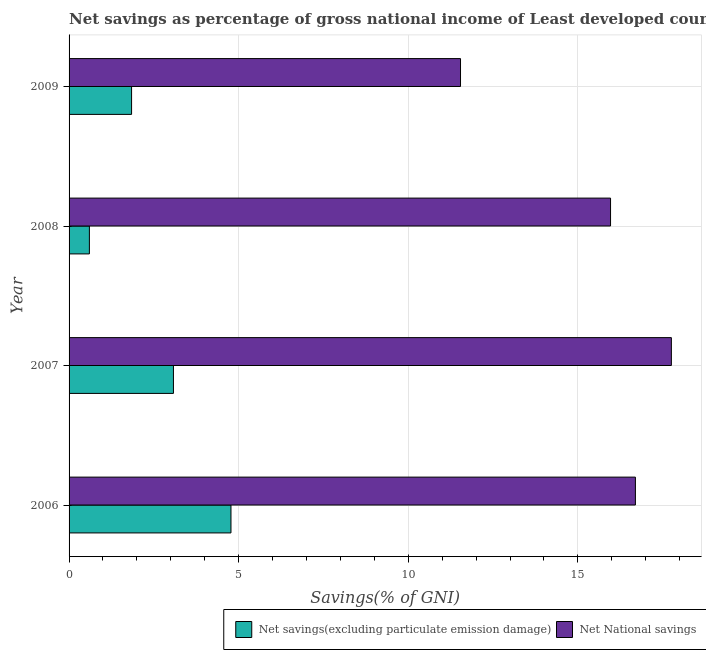Are the number of bars per tick equal to the number of legend labels?
Your answer should be compact. Yes. How many bars are there on the 4th tick from the top?
Offer a very short reply. 2. In how many cases, is the number of bars for a given year not equal to the number of legend labels?
Your answer should be compact. 0. What is the net savings(excluding particulate emission damage) in 2006?
Keep it short and to the point. 4.77. Across all years, what is the maximum net savings(excluding particulate emission damage)?
Your answer should be compact. 4.77. Across all years, what is the minimum net national savings?
Offer a very short reply. 11.54. In which year was the net savings(excluding particulate emission damage) maximum?
Offer a very short reply. 2006. In which year was the net national savings minimum?
Make the answer very short. 2009. What is the total net national savings in the graph?
Your answer should be compact. 61.96. What is the difference between the net savings(excluding particulate emission damage) in 2007 and that in 2008?
Your answer should be compact. 2.48. What is the difference between the net national savings in 2006 and the net savings(excluding particulate emission damage) in 2008?
Ensure brevity in your answer.  16.1. What is the average net national savings per year?
Keep it short and to the point. 15.49. In the year 2006, what is the difference between the net savings(excluding particulate emission damage) and net national savings?
Provide a short and direct response. -11.92. What is the ratio of the net national savings in 2006 to that in 2007?
Provide a short and direct response. 0.94. Is the difference between the net national savings in 2006 and 2007 greater than the difference between the net savings(excluding particulate emission damage) in 2006 and 2007?
Provide a short and direct response. No. What is the difference between the highest and the second highest net national savings?
Your response must be concise. 1.06. What is the difference between the highest and the lowest net national savings?
Your answer should be compact. 6.22. What does the 1st bar from the top in 2009 represents?
Offer a terse response. Net National savings. What does the 2nd bar from the bottom in 2008 represents?
Offer a very short reply. Net National savings. How many bars are there?
Your response must be concise. 8. Are all the bars in the graph horizontal?
Your answer should be compact. Yes. How many years are there in the graph?
Offer a terse response. 4. What is the difference between two consecutive major ticks on the X-axis?
Your answer should be very brief. 5. Are the values on the major ticks of X-axis written in scientific E-notation?
Your response must be concise. No. Does the graph contain grids?
Ensure brevity in your answer.  Yes. How many legend labels are there?
Your answer should be very brief. 2. How are the legend labels stacked?
Your answer should be very brief. Horizontal. What is the title of the graph?
Ensure brevity in your answer.  Net savings as percentage of gross national income of Least developed countries. What is the label or title of the X-axis?
Your answer should be compact. Savings(% of GNI). What is the label or title of the Y-axis?
Provide a succinct answer. Year. What is the Savings(% of GNI) in Net savings(excluding particulate emission damage) in 2006?
Provide a short and direct response. 4.77. What is the Savings(% of GNI) in Net National savings in 2006?
Give a very brief answer. 16.7. What is the Savings(% of GNI) of Net savings(excluding particulate emission damage) in 2007?
Your answer should be very brief. 3.08. What is the Savings(% of GNI) in Net National savings in 2007?
Your answer should be compact. 17.76. What is the Savings(% of GNI) of Net savings(excluding particulate emission damage) in 2008?
Your answer should be very brief. 0.6. What is the Savings(% of GNI) of Net National savings in 2008?
Ensure brevity in your answer.  15.96. What is the Savings(% of GNI) of Net savings(excluding particulate emission damage) in 2009?
Your answer should be very brief. 1.84. What is the Savings(% of GNI) of Net National savings in 2009?
Your answer should be compact. 11.54. Across all years, what is the maximum Savings(% of GNI) in Net savings(excluding particulate emission damage)?
Provide a short and direct response. 4.77. Across all years, what is the maximum Savings(% of GNI) of Net National savings?
Provide a succinct answer. 17.76. Across all years, what is the minimum Savings(% of GNI) in Net savings(excluding particulate emission damage)?
Keep it short and to the point. 0.6. Across all years, what is the minimum Savings(% of GNI) in Net National savings?
Your answer should be compact. 11.54. What is the total Savings(% of GNI) in Net savings(excluding particulate emission damage) in the graph?
Provide a short and direct response. 10.29. What is the total Savings(% of GNI) of Net National savings in the graph?
Make the answer very short. 61.96. What is the difference between the Savings(% of GNI) of Net savings(excluding particulate emission damage) in 2006 and that in 2007?
Your answer should be very brief. 1.7. What is the difference between the Savings(% of GNI) of Net National savings in 2006 and that in 2007?
Give a very brief answer. -1.06. What is the difference between the Savings(% of GNI) in Net savings(excluding particulate emission damage) in 2006 and that in 2008?
Provide a short and direct response. 4.17. What is the difference between the Savings(% of GNI) of Net National savings in 2006 and that in 2008?
Your answer should be compact. 0.73. What is the difference between the Savings(% of GNI) of Net savings(excluding particulate emission damage) in 2006 and that in 2009?
Your answer should be very brief. 2.93. What is the difference between the Savings(% of GNI) in Net National savings in 2006 and that in 2009?
Provide a succinct answer. 5.16. What is the difference between the Savings(% of GNI) of Net savings(excluding particulate emission damage) in 2007 and that in 2008?
Provide a succinct answer. 2.48. What is the difference between the Savings(% of GNI) in Net National savings in 2007 and that in 2008?
Offer a terse response. 1.79. What is the difference between the Savings(% of GNI) in Net savings(excluding particulate emission damage) in 2007 and that in 2009?
Make the answer very short. 1.23. What is the difference between the Savings(% of GNI) in Net National savings in 2007 and that in 2009?
Keep it short and to the point. 6.22. What is the difference between the Savings(% of GNI) of Net savings(excluding particulate emission damage) in 2008 and that in 2009?
Keep it short and to the point. -1.24. What is the difference between the Savings(% of GNI) of Net National savings in 2008 and that in 2009?
Keep it short and to the point. 4.42. What is the difference between the Savings(% of GNI) of Net savings(excluding particulate emission damage) in 2006 and the Savings(% of GNI) of Net National savings in 2007?
Make the answer very short. -12.98. What is the difference between the Savings(% of GNI) of Net savings(excluding particulate emission damage) in 2006 and the Savings(% of GNI) of Net National savings in 2008?
Offer a terse response. -11.19. What is the difference between the Savings(% of GNI) in Net savings(excluding particulate emission damage) in 2006 and the Savings(% of GNI) in Net National savings in 2009?
Give a very brief answer. -6.77. What is the difference between the Savings(% of GNI) of Net savings(excluding particulate emission damage) in 2007 and the Savings(% of GNI) of Net National savings in 2008?
Your response must be concise. -12.89. What is the difference between the Savings(% of GNI) of Net savings(excluding particulate emission damage) in 2007 and the Savings(% of GNI) of Net National savings in 2009?
Provide a short and direct response. -8.46. What is the difference between the Savings(% of GNI) of Net savings(excluding particulate emission damage) in 2008 and the Savings(% of GNI) of Net National savings in 2009?
Provide a succinct answer. -10.94. What is the average Savings(% of GNI) of Net savings(excluding particulate emission damage) per year?
Your response must be concise. 2.57. What is the average Savings(% of GNI) of Net National savings per year?
Your answer should be compact. 15.49. In the year 2006, what is the difference between the Savings(% of GNI) in Net savings(excluding particulate emission damage) and Savings(% of GNI) in Net National savings?
Provide a succinct answer. -11.92. In the year 2007, what is the difference between the Savings(% of GNI) of Net savings(excluding particulate emission damage) and Savings(% of GNI) of Net National savings?
Your response must be concise. -14.68. In the year 2008, what is the difference between the Savings(% of GNI) of Net savings(excluding particulate emission damage) and Savings(% of GNI) of Net National savings?
Offer a very short reply. -15.37. In the year 2009, what is the difference between the Savings(% of GNI) in Net savings(excluding particulate emission damage) and Savings(% of GNI) in Net National savings?
Your response must be concise. -9.7. What is the ratio of the Savings(% of GNI) in Net savings(excluding particulate emission damage) in 2006 to that in 2007?
Make the answer very short. 1.55. What is the ratio of the Savings(% of GNI) in Net National savings in 2006 to that in 2007?
Provide a short and direct response. 0.94. What is the ratio of the Savings(% of GNI) in Net savings(excluding particulate emission damage) in 2006 to that in 2008?
Provide a short and direct response. 7.97. What is the ratio of the Savings(% of GNI) in Net National savings in 2006 to that in 2008?
Give a very brief answer. 1.05. What is the ratio of the Savings(% of GNI) in Net savings(excluding particulate emission damage) in 2006 to that in 2009?
Give a very brief answer. 2.59. What is the ratio of the Savings(% of GNI) in Net National savings in 2006 to that in 2009?
Your response must be concise. 1.45. What is the ratio of the Savings(% of GNI) in Net savings(excluding particulate emission damage) in 2007 to that in 2008?
Give a very brief answer. 5.14. What is the ratio of the Savings(% of GNI) of Net National savings in 2007 to that in 2008?
Give a very brief answer. 1.11. What is the ratio of the Savings(% of GNI) in Net savings(excluding particulate emission damage) in 2007 to that in 2009?
Provide a short and direct response. 1.67. What is the ratio of the Savings(% of GNI) of Net National savings in 2007 to that in 2009?
Ensure brevity in your answer.  1.54. What is the ratio of the Savings(% of GNI) of Net savings(excluding particulate emission damage) in 2008 to that in 2009?
Ensure brevity in your answer.  0.33. What is the ratio of the Savings(% of GNI) in Net National savings in 2008 to that in 2009?
Your response must be concise. 1.38. What is the difference between the highest and the second highest Savings(% of GNI) of Net savings(excluding particulate emission damage)?
Keep it short and to the point. 1.7. What is the difference between the highest and the second highest Savings(% of GNI) in Net National savings?
Ensure brevity in your answer.  1.06. What is the difference between the highest and the lowest Savings(% of GNI) in Net savings(excluding particulate emission damage)?
Make the answer very short. 4.17. What is the difference between the highest and the lowest Savings(% of GNI) in Net National savings?
Ensure brevity in your answer.  6.22. 